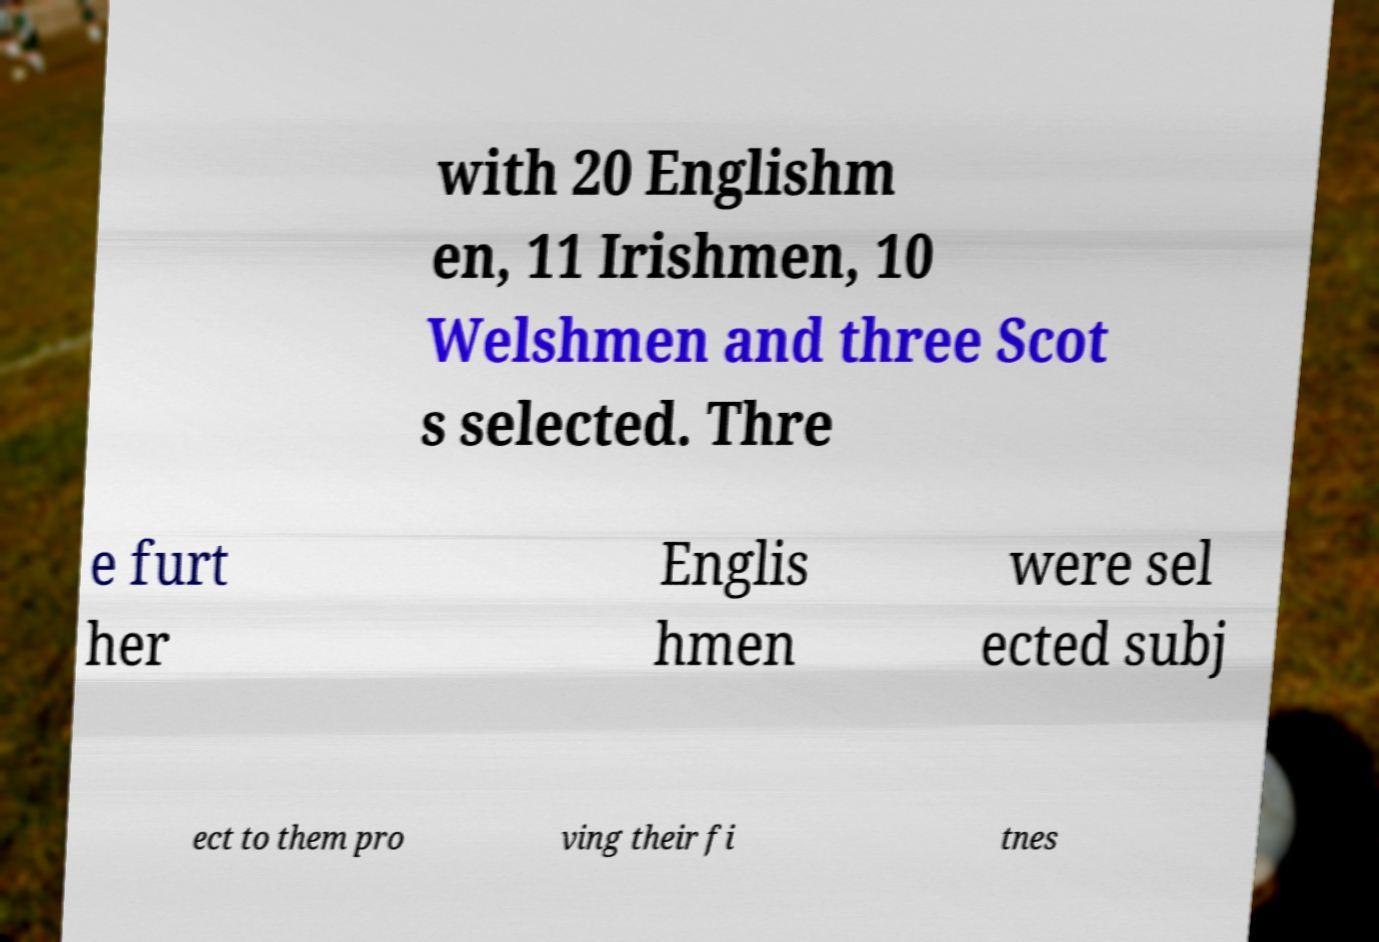Please identify and transcribe the text found in this image. with 20 Englishm en, 11 Irishmen, 10 Welshmen and three Scot s selected. Thre e furt her Englis hmen were sel ected subj ect to them pro ving their fi tnes 